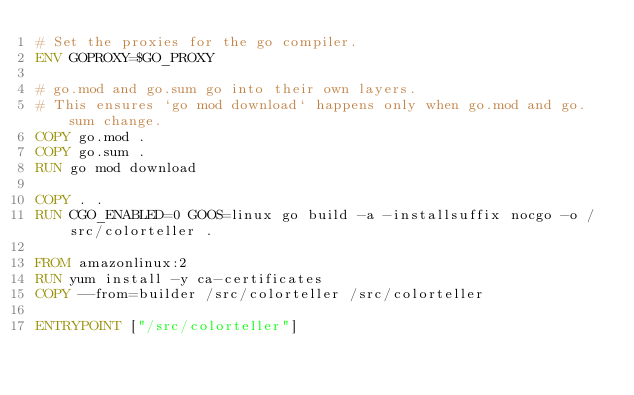<code> <loc_0><loc_0><loc_500><loc_500><_Dockerfile_># Set the proxies for the go compiler.
ENV GOPROXY=$GO_PROXY

# go.mod and go.sum go into their own layers.
# This ensures `go mod download` happens only when go.mod and go.sum change.
COPY go.mod .
COPY go.sum .
RUN go mod download

COPY . .
RUN CGO_ENABLED=0 GOOS=linux go build -a -installsuffix nocgo -o /src/colorteller .

FROM amazonlinux:2
RUN yum install -y ca-certificates
COPY --from=builder /src/colorteller /src/colorteller

ENTRYPOINT ["/src/colorteller"]
</code> 